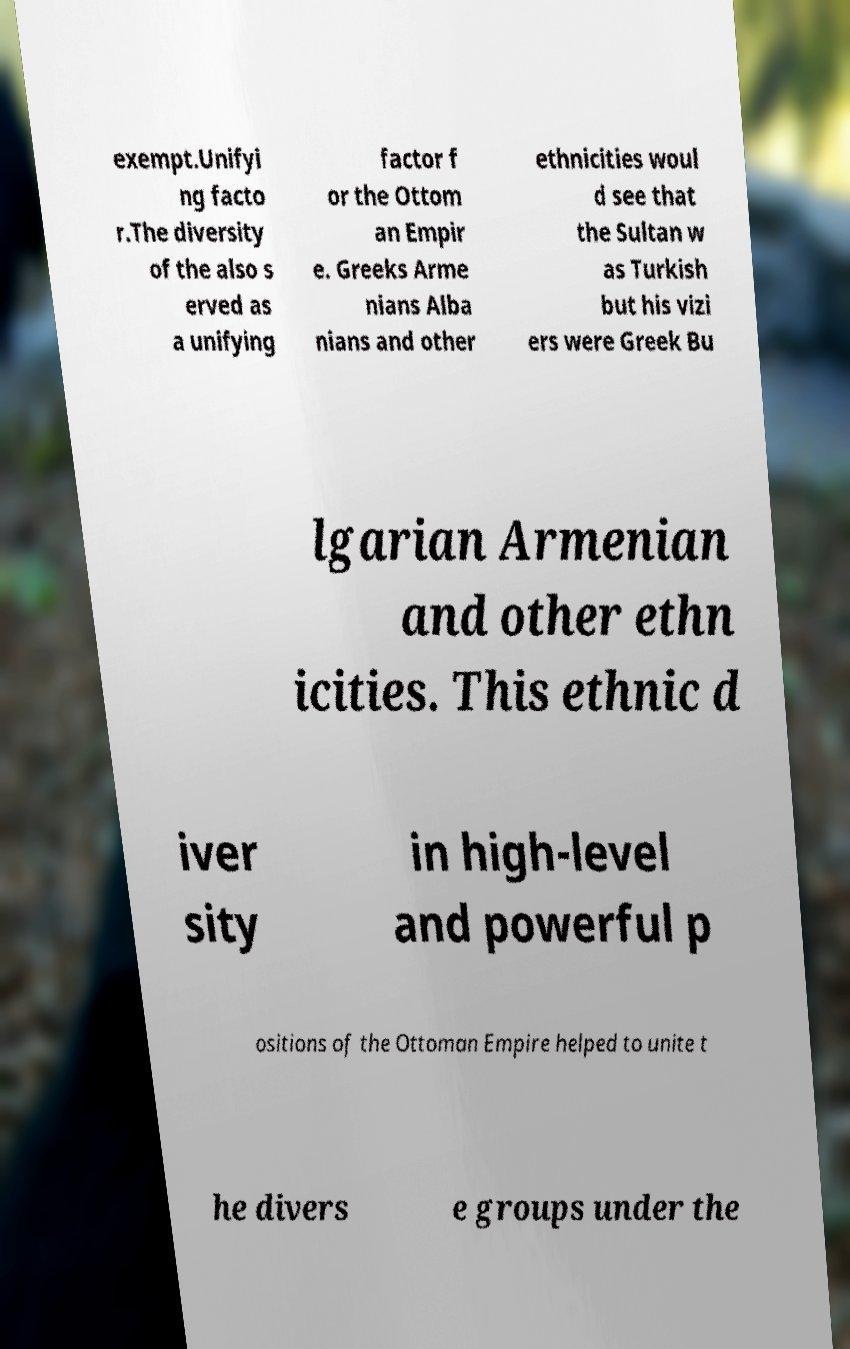For documentation purposes, I need the text within this image transcribed. Could you provide that? exempt.Unifyi ng facto r.The diversity of the also s erved as a unifying factor f or the Ottom an Empir e. Greeks Arme nians Alba nians and other ethnicities woul d see that the Sultan w as Turkish but his vizi ers were Greek Bu lgarian Armenian and other ethn icities. This ethnic d iver sity in high-level and powerful p ositions of the Ottoman Empire helped to unite t he divers e groups under the 